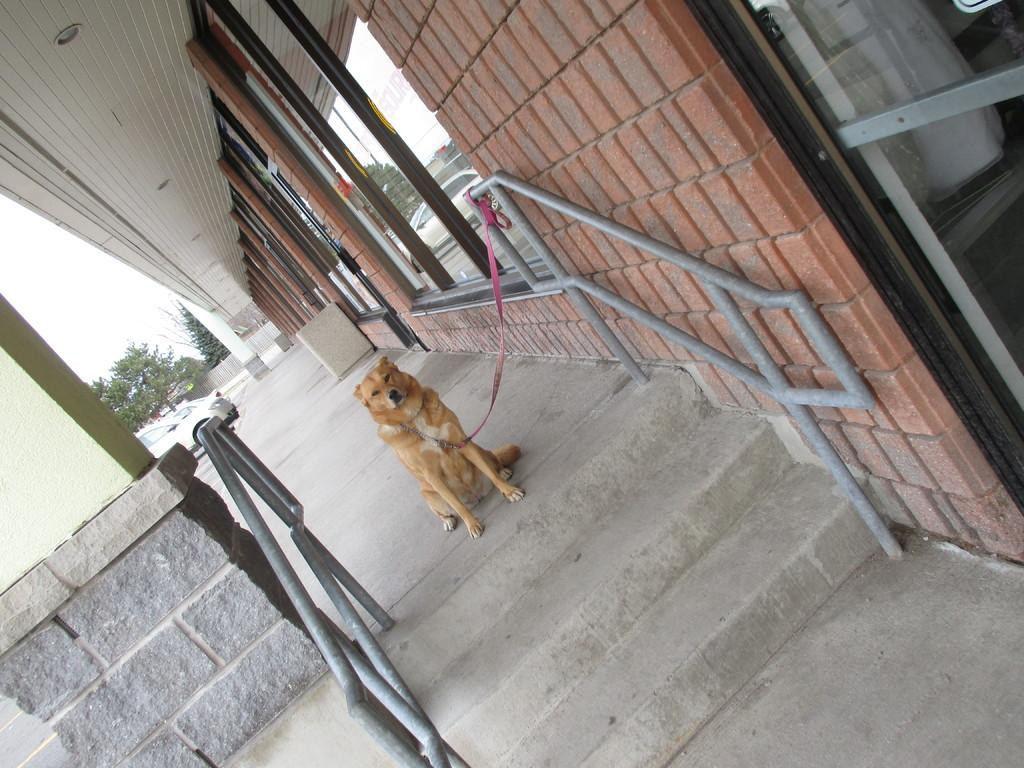What animal can be seen in the image? There is a dog in the image. How is the dog secured in the image? The dog is tied with a belt to a metal rod. What can be seen in the background of the image? There is a building, trees, and cars in the background of the image. What type of breakfast is the dog eating in the image? There is no breakfast present in the image; the dog is tied to a metal rod with a belt. 